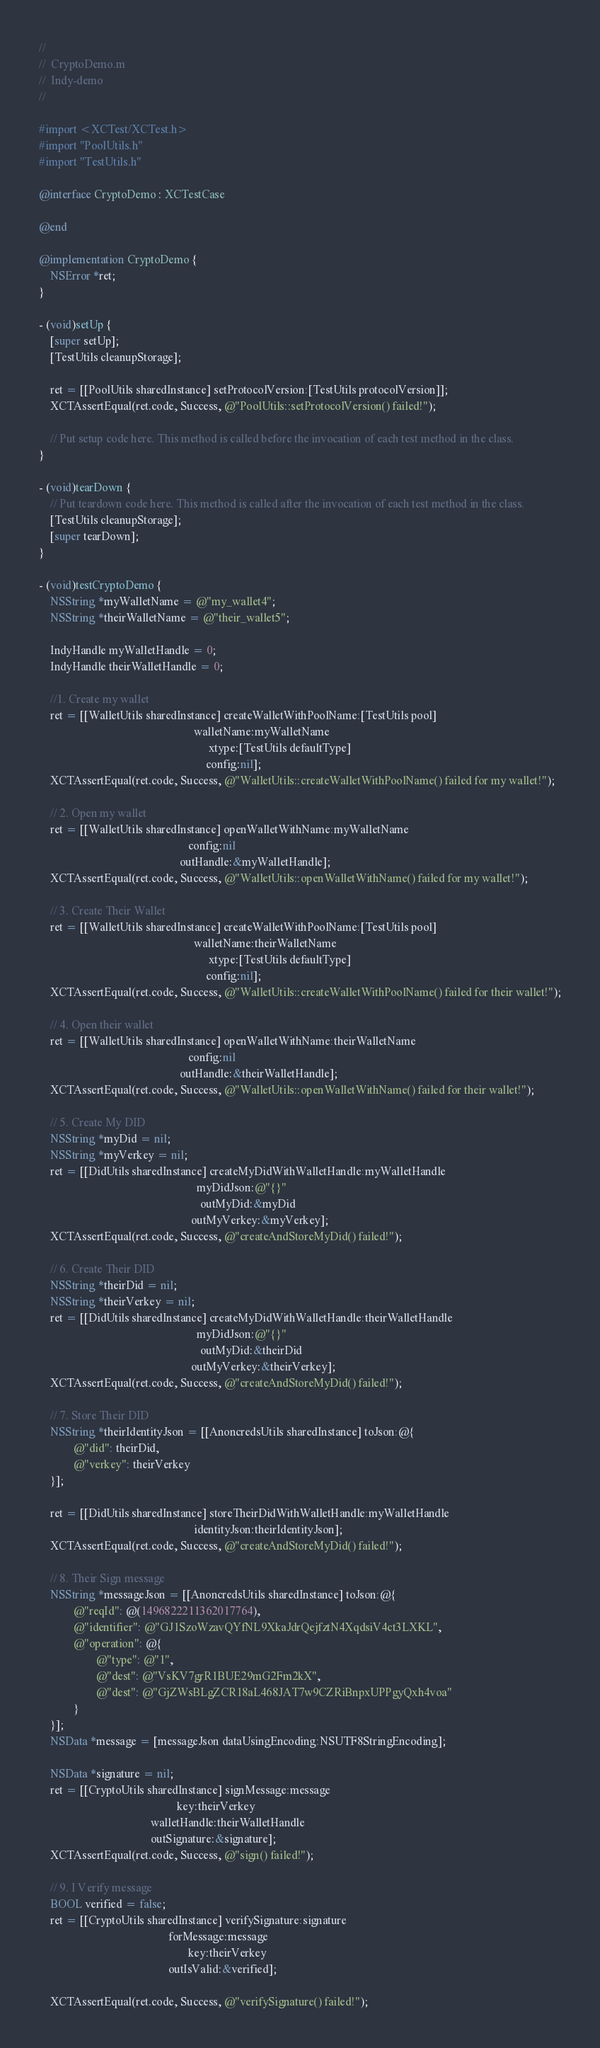<code> <loc_0><loc_0><loc_500><loc_500><_ObjectiveC_>//
//  CryptoDemo.m
//  Indy-demo
//

#import <XCTest/XCTest.h>
#import "PoolUtils.h"
#import "TestUtils.h"

@interface CryptoDemo : XCTestCase

@end

@implementation CryptoDemo {
    NSError *ret;
}

- (void)setUp {
    [super setUp];
    [TestUtils cleanupStorage];

    ret = [[PoolUtils sharedInstance] setProtocolVersion:[TestUtils protocolVersion]];
    XCTAssertEqual(ret.code, Success, @"PoolUtils::setProtocolVersion() failed!");

    // Put setup code here. This method is called before the invocation of each test method in the class.
}

- (void)tearDown {
    // Put teardown code here. This method is called after the invocation of each test method in the class.
    [TestUtils cleanupStorage];
    [super tearDown];
}

- (void)testCryptoDemo {
    NSString *myWalletName = @"my_wallet4";
    NSString *theirWalletName = @"their_wallet5";

    IndyHandle myWalletHandle = 0;
    IndyHandle theirWalletHandle = 0;

    //1. Create my wallet
    ret = [[WalletUtils sharedInstance] createWalletWithPoolName:[TestUtils pool]
                                                      walletName:myWalletName
                                                           xtype:[TestUtils defaultType]
                                                          config:nil];
    XCTAssertEqual(ret.code, Success, @"WalletUtils::createWalletWithPoolName() failed for my wallet!");

    // 2. Open my wallet
    ret = [[WalletUtils sharedInstance] openWalletWithName:myWalletName
                                                    config:nil
                                                 outHandle:&myWalletHandle];
    XCTAssertEqual(ret.code, Success, @"WalletUtils::openWalletWithName() failed for my wallet!");

    // 3. Create Their Wallet
    ret = [[WalletUtils sharedInstance] createWalletWithPoolName:[TestUtils pool]
                                                      walletName:theirWalletName
                                                           xtype:[TestUtils defaultType]
                                                          config:nil];
    XCTAssertEqual(ret.code, Success, @"WalletUtils::createWalletWithPoolName() failed for their wallet!");

    // 4. Open their wallet
    ret = [[WalletUtils sharedInstance] openWalletWithName:theirWalletName
                                                    config:nil
                                                 outHandle:&theirWalletHandle];
    XCTAssertEqual(ret.code, Success, @"WalletUtils::openWalletWithName() failed for their wallet!");

    // 5. Create My DID
    NSString *myDid = nil;
    NSString *myVerkey = nil;
    ret = [[DidUtils sharedInstance] createMyDidWithWalletHandle:myWalletHandle
                                                       myDidJson:@"{}"
                                                        outMyDid:&myDid
                                                     outMyVerkey:&myVerkey];
    XCTAssertEqual(ret.code, Success, @"createAndStoreMyDid() failed!");

    // 6. Create Their DID
    NSString *theirDid = nil;
    NSString *theirVerkey = nil;
    ret = [[DidUtils sharedInstance] createMyDidWithWalletHandle:theirWalletHandle
                                                       myDidJson:@"{}"
                                                        outMyDid:&theirDid
                                                     outMyVerkey:&theirVerkey];
    XCTAssertEqual(ret.code, Success, @"createAndStoreMyDid() failed!");

    // 7. Store Their DID
    NSString *theirIdentityJson = [[AnoncredsUtils sharedInstance] toJson:@{
            @"did": theirDid,
            @"verkey": theirVerkey
    }];

    ret = [[DidUtils sharedInstance] storeTheirDidWithWalletHandle:myWalletHandle
                                                      identityJson:theirIdentityJson];
    XCTAssertEqual(ret.code, Success, @"createAndStoreMyDid() failed!");

    // 8. Their Sign message
    NSString *messageJson = [[AnoncredsUtils sharedInstance] toJson:@{
            @"reqId": @(1496822211362017764),
            @"identifier": @"GJ1SzoWzavQYfNL9XkaJdrQejfztN4XqdsiV4ct3LXKL",
            @"operation": @{
                    @"type": @"1",
                    @"dest": @"VsKV7grR1BUE29mG2Fm2kX",
                    @"dest": @"GjZWsBLgZCR18aL468JAT7w9CZRiBnpxUPPgyQxh4voa"
            }
    }];
    NSData *message = [messageJson dataUsingEncoding:NSUTF8StringEncoding];

    NSData *signature = nil;
    ret = [[CryptoUtils sharedInstance] signMessage:message
                                                key:theirVerkey
                                       walletHandle:theirWalletHandle
                                       outSignature:&signature];
    XCTAssertEqual(ret.code, Success, @"sign() failed!");

    // 9. I Verify message
    BOOL verified = false;
    ret = [[CryptoUtils sharedInstance] verifySignature:signature
                                             forMessage:message
                                                    key:theirVerkey
                                             outIsValid:&verified];

    XCTAssertEqual(ret.code, Success, @"verifySignature() failed!");</code> 